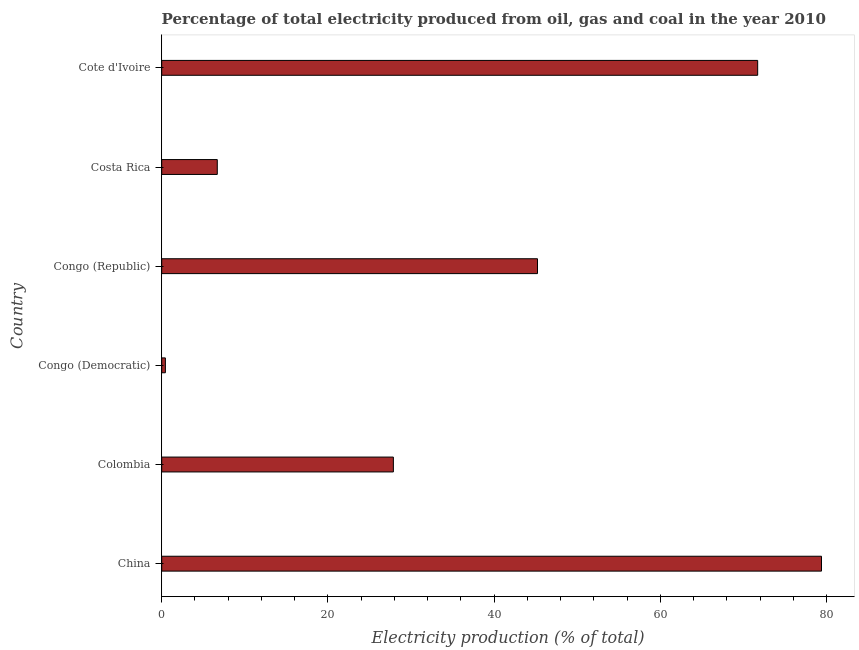Does the graph contain any zero values?
Your answer should be compact. No. Does the graph contain grids?
Your answer should be compact. No. What is the title of the graph?
Provide a short and direct response. Percentage of total electricity produced from oil, gas and coal in the year 2010. What is the label or title of the X-axis?
Give a very brief answer. Electricity production (% of total). What is the label or title of the Y-axis?
Make the answer very short. Country. What is the electricity production in China?
Make the answer very short. 79.4. Across all countries, what is the maximum electricity production?
Provide a short and direct response. 79.4. Across all countries, what is the minimum electricity production?
Ensure brevity in your answer.  0.44. In which country was the electricity production maximum?
Your answer should be compact. China. In which country was the electricity production minimum?
Give a very brief answer. Congo (Democratic). What is the sum of the electricity production?
Make the answer very short. 231.35. What is the difference between the electricity production in Colombia and Congo (Democratic)?
Give a very brief answer. 27.44. What is the average electricity production per country?
Keep it short and to the point. 38.56. What is the median electricity production?
Your answer should be compact. 36.55. In how many countries, is the electricity production greater than 16 %?
Your answer should be compact. 4. What is the ratio of the electricity production in Congo (Democratic) to that in Cote d'Ivoire?
Your answer should be very brief. 0.01. Is the electricity production in Colombia less than that in Cote d'Ivoire?
Keep it short and to the point. Yes. What is the difference between the highest and the second highest electricity production?
Your answer should be very brief. 7.68. What is the difference between the highest and the lowest electricity production?
Give a very brief answer. 78.96. In how many countries, is the electricity production greater than the average electricity production taken over all countries?
Keep it short and to the point. 3. How many bars are there?
Keep it short and to the point. 6. How many countries are there in the graph?
Offer a very short reply. 6. What is the difference between two consecutive major ticks on the X-axis?
Your response must be concise. 20. Are the values on the major ticks of X-axis written in scientific E-notation?
Offer a very short reply. No. What is the Electricity production (% of total) of China?
Your answer should be compact. 79.4. What is the Electricity production (% of total) of Colombia?
Keep it short and to the point. 27.88. What is the Electricity production (% of total) in Congo (Democratic)?
Make the answer very short. 0.44. What is the Electricity production (% of total) in Congo (Republic)?
Give a very brief answer. 45.22. What is the Electricity production (% of total) in Costa Rica?
Your response must be concise. 6.69. What is the Electricity production (% of total) in Cote d'Ivoire?
Make the answer very short. 71.72. What is the difference between the Electricity production (% of total) in China and Colombia?
Provide a short and direct response. 51.52. What is the difference between the Electricity production (% of total) in China and Congo (Democratic)?
Your answer should be very brief. 78.96. What is the difference between the Electricity production (% of total) in China and Congo (Republic)?
Provide a short and direct response. 34.18. What is the difference between the Electricity production (% of total) in China and Costa Rica?
Your answer should be compact. 72.71. What is the difference between the Electricity production (% of total) in China and Cote d'Ivoire?
Offer a terse response. 7.68. What is the difference between the Electricity production (% of total) in Colombia and Congo (Democratic)?
Your answer should be compact. 27.44. What is the difference between the Electricity production (% of total) in Colombia and Congo (Republic)?
Your response must be concise. -17.34. What is the difference between the Electricity production (% of total) in Colombia and Costa Rica?
Ensure brevity in your answer.  21.19. What is the difference between the Electricity production (% of total) in Colombia and Cote d'Ivoire?
Your response must be concise. -43.84. What is the difference between the Electricity production (% of total) in Congo (Democratic) and Congo (Republic)?
Provide a short and direct response. -44.78. What is the difference between the Electricity production (% of total) in Congo (Democratic) and Costa Rica?
Your response must be concise. -6.24. What is the difference between the Electricity production (% of total) in Congo (Democratic) and Cote d'Ivoire?
Provide a short and direct response. -71.27. What is the difference between the Electricity production (% of total) in Congo (Republic) and Costa Rica?
Ensure brevity in your answer.  38.53. What is the difference between the Electricity production (% of total) in Congo (Republic) and Cote d'Ivoire?
Your answer should be compact. -26.5. What is the difference between the Electricity production (% of total) in Costa Rica and Cote d'Ivoire?
Your answer should be compact. -65.03. What is the ratio of the Electricity production (% of total) in China to that in Colombia?
Offer a very short reply. 2.85. What is the ratio of the Electricity production (% of total) in China to that in Congo (Democratic)?
Offer a terse response. 178.97. What is the ratio of the Electricity production (% of total) in China to that in Congo (Republic)?
Offer a terse response. 1.76. What is the ratio of the Electricity production (% of total) in China to that in Costa Rica?
Provide a short and direct response. 11.87. What is the ratio of the Electricity production (% of total) in China to that in Cote d'Ivoire?
Provide a short and direct response. 1.11. What is the ratio of the Electricity production (% of total) in Colombia to that in Congo (Democratic)?
Your answer should be compact. 62.84. What is the ratio of the Electricity production (% of total) in Colombia to that in Congo (Republic)?
Provide a short and direct response. 0.62. What is the ratio of the Electricity production (% of total) in Colombia to that in Costa Rica?
Give a very brief answer. 4.17. What is the ratio of the Electricity production (% of total) in Colombia to that in Cote d'Ivoire?
Make the answer very short. 0.39. What is the ratio of the Electricity production (% of total) in Congo (Democratic) to that in Congo (Republic)?
Your answer should be very brief. 0.01. What is the ratio of the Electricity production (% of total) in Congo (Democratic) to that in Costa Rica?
Make the answer very short. 0.07. What is the ratio of the Electricity production (% of total) in Congo (Democratic) to that in Cote d'Ivoire?
Offer a terse response. 0.01. What is the ratio of the Electricity production (% of total) in Congo (Republic) to that in Costa Rica?
Give a very brief answer. 6.76. What is the ratio of the Electricity production (% of total) in Congo (Republic) to that in Cote d'Ivoire?
Make the answer very short. 0.63. What is the ratio of the Electricity production (% of total) in Costa Rica to that in Cote d'Ivoire?
Keep it short and to the point. 0.09. 